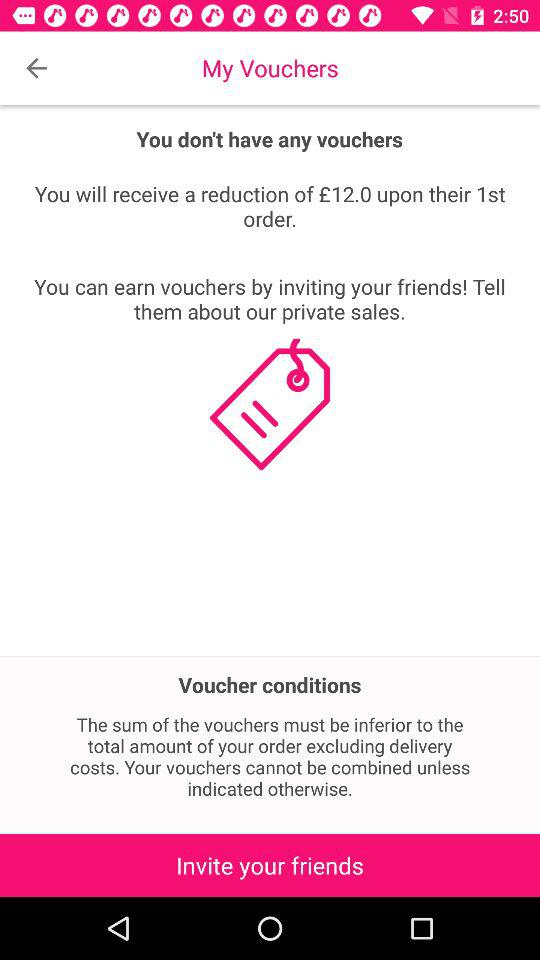How much is the discount for inviting a friend?
Answer the question using a single word or phrase. £12.0 